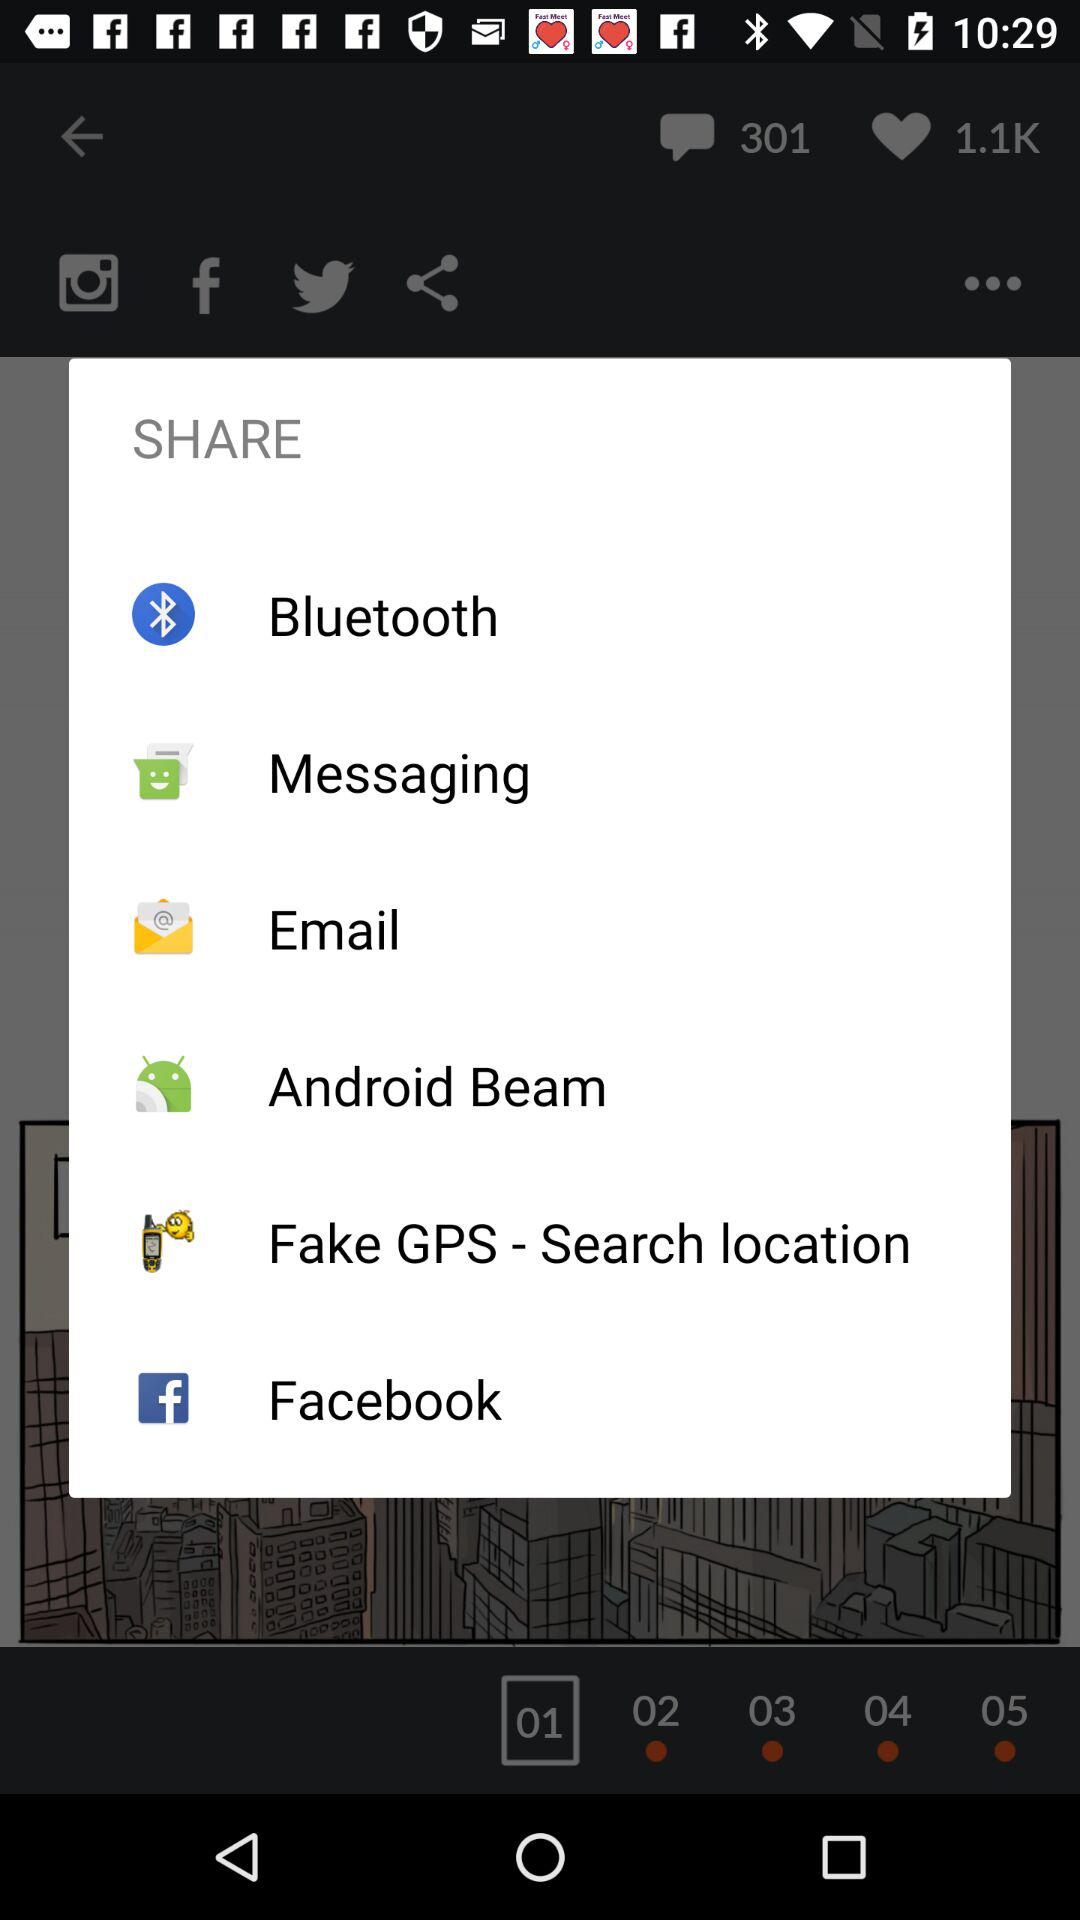What are the apps that can be used to share the content? The apps "Bluetooth", "Messaging", "Email", "Android Beam", "Fake GPS - Search location" and "Facebook" can be used to share the content. 